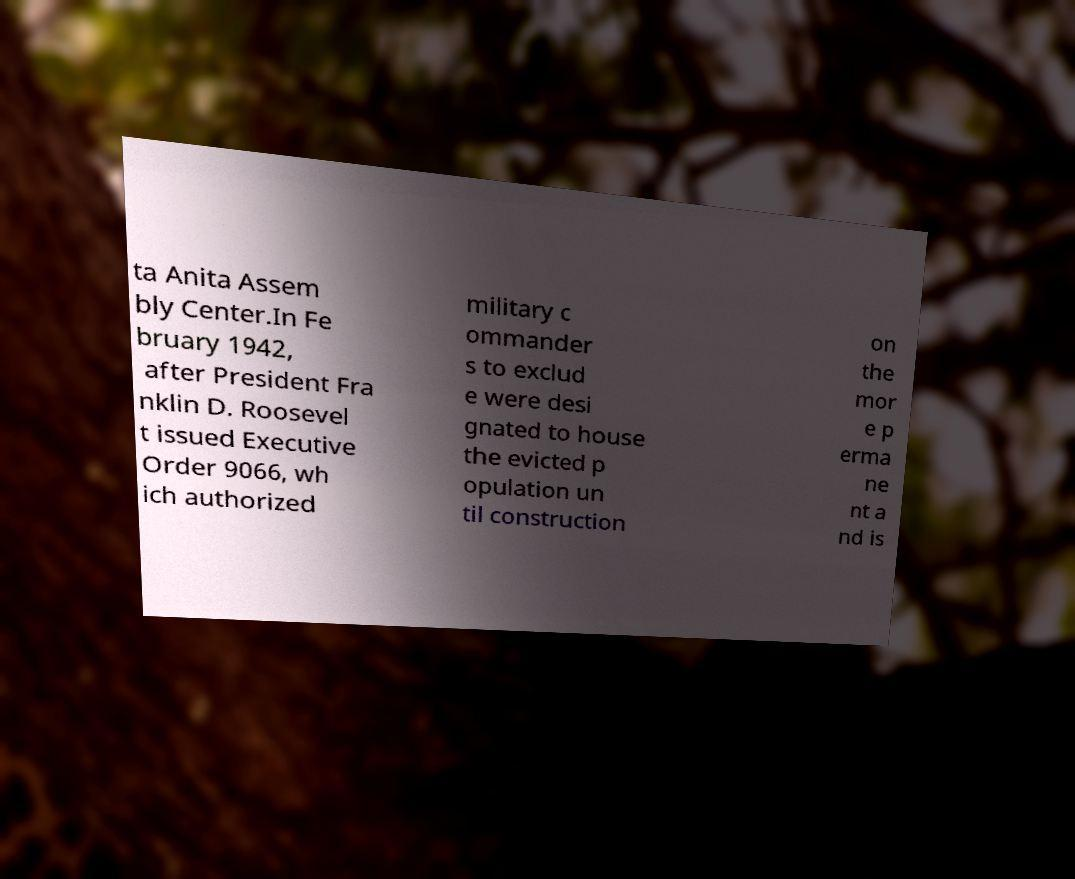Could you assist in decoding the text presented in this image and type it out clearly? ta Anita Assem bly Center.In Fe bruary 1942, after President Fra nklin D. Roosevel t issued Executive Order 9066, wh ich authorized military c ommander s to exclud e were desi gnated to house the evicted p opulation un til construction on the mor e p erma ne nt a nd is 